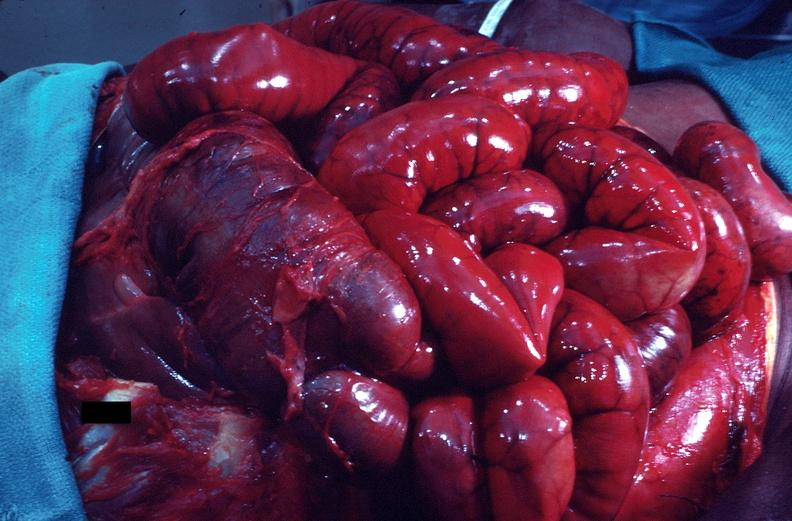s gastrointestinal present?
Answer the question using a single word or phrase. Yes 